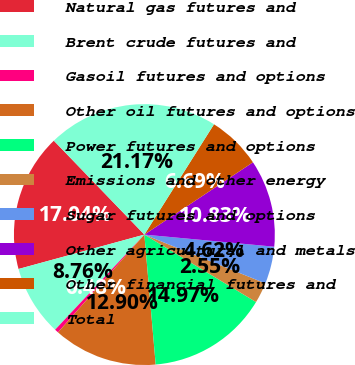<chart> <loc_0><loc_0><loc_500><loc_500><pie_chart><fcel>Natural gas futures and<fcel>Brent crude futures and<fcel>Gasoil futures and options<fcel>Other oil futures and options<fcel>Power futures and options<fcel>Emissions and other energy<fcel>Sugar futures and options<fcel>Other agricultural and metals<fcel>Other financial futures and<fcel>Total<nl><fcel>17.04%<fcel>8.76%<fcel>0.48%<fcel>12.9%<fcel>14.97%<fcel>2.55%<fcel>4.62%<fcel>10.83%<fcel>6.69%<fcel>21.17%<nl></chart> 